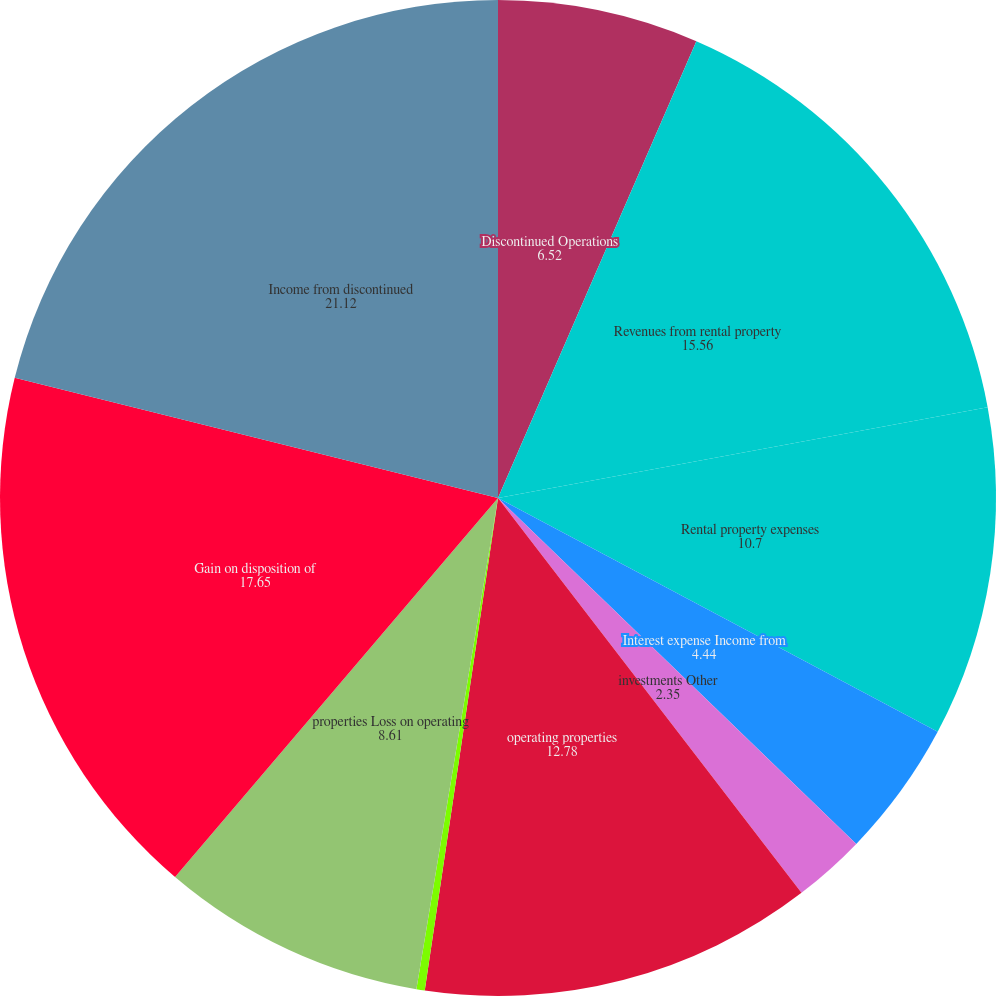Convert chart to OTSL. <chart><loc_0><loc_0><loc_500><loc_500><pie_chart><fcel>Discontinued Operations<fcel>Revenues from rental property<fcel>Rental property expenses<fcel>Interest expense Income from<fcel>investments Other<fcel>operating properties<fcel>from discontinued operating<fcel>properties Loss on operating<fcel>Gain on disposition of<fcel>Income from discontinued<nl><fcel>6.52%<fcel>15.56%<fcel>10.7%<fcel>4.44%<fcel>2.35%<fcel>12.78%<fcel>0.27%<fcel>8.61%<fcel>17.65%<fcel>21.12%<nl></chart> 